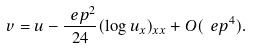Convert formula to latex. <formula><loc_0><loc_0><loc_500><loc_500>v = u - \frac { \ e p ^ { 2 } } { 2 4 } ( \log u _ { x } ) _ { x x } + O ( \ e p ^ { 4 } ) .</formula> 